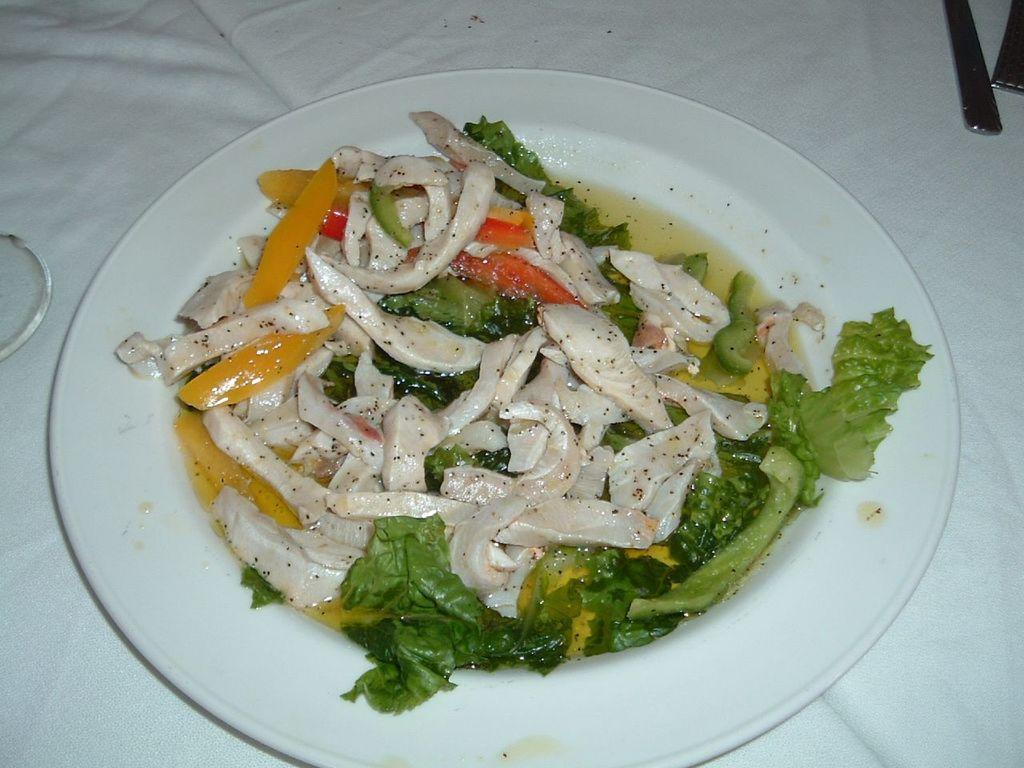Can you describe this image briefly? In this picture we can see food on the plate and some objects. 